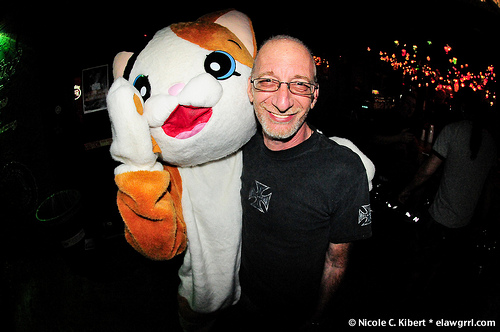<image>
Is the cat costume on the man? Yes. Looking at the image, I can see the cat costume is positioned on top of the man, with the man providing support. Is there a toy on the man? Yes. Looking at the image, I can see the toy is positioned on top of the man, with the man providing support. 